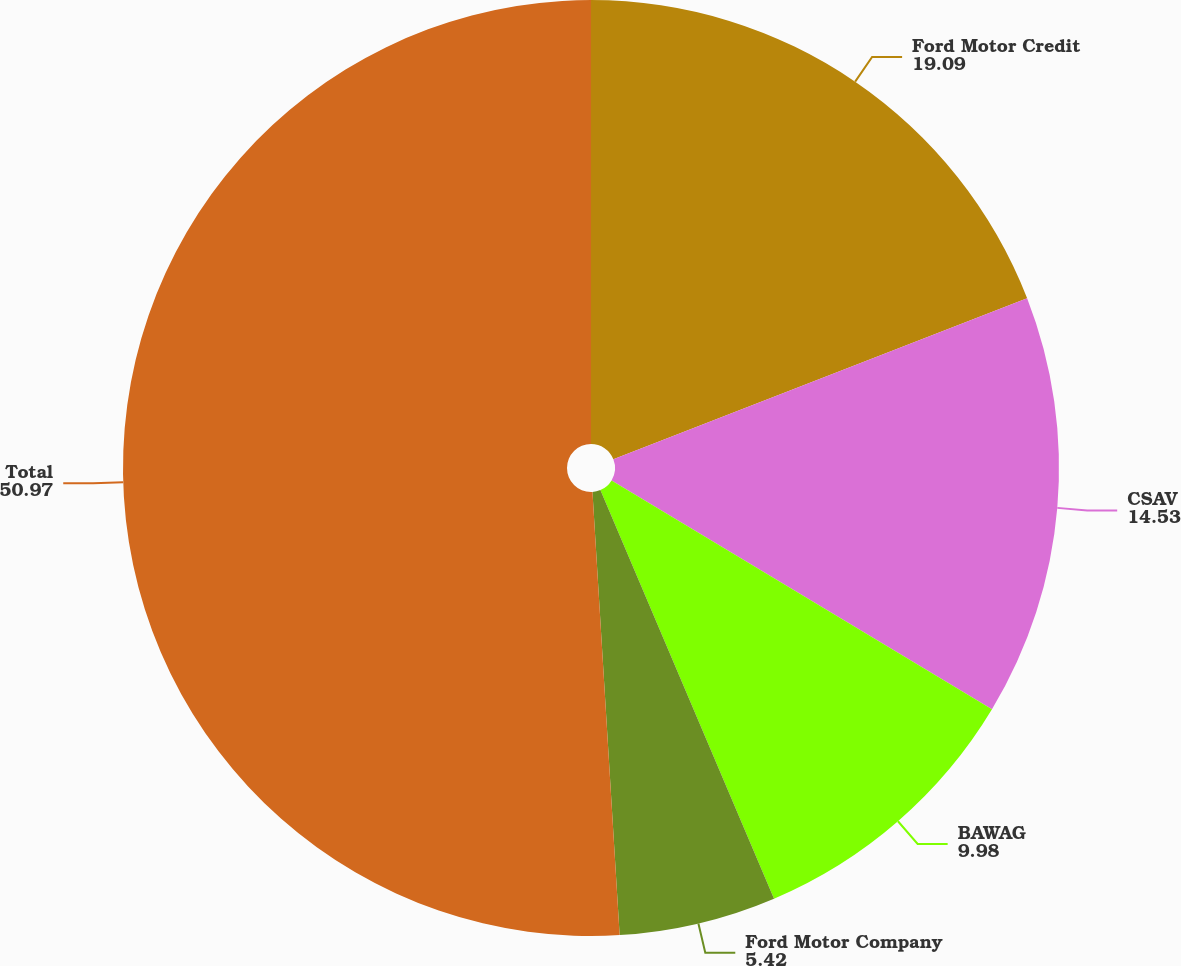Convert chart to OTSL. <chart><loc_0><loc_0><loc_500><loc_500><pie_chart><fcel>Ford Motor Credit<fcel>CSAV<fcel>BAWAG<fcel>Ford Motor Company<fcel>Total<nl><fcel>19.09%<fcel>14.53%<fcel>9.98%<fcel>5.42%<fcel>50.97%<nl></chart> 